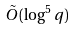<formula> <loc_0><loc_0><loc_500><loc_500>\tilde { O } ( \log ^ { 5 } q )</formula> 